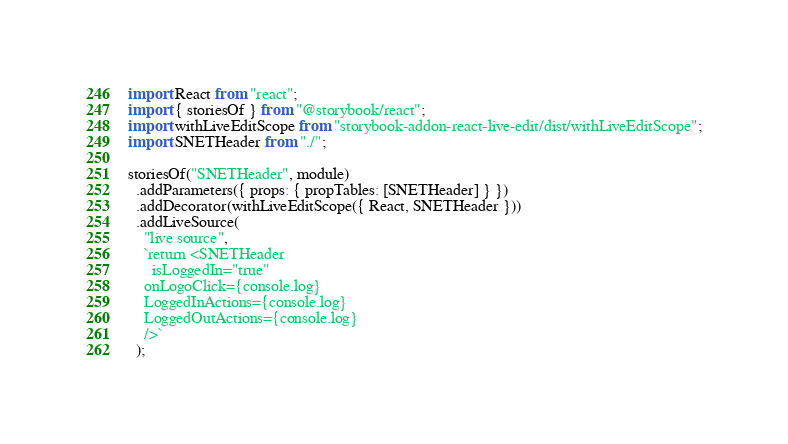<code> <loc_0><loc_0><loc_500><loc_500><_JavaScript_>import React from "react";
import { storiesOf } from "@storybook/react";
import withLiveEditScope from "storybook-addon-react-live-edit/dist/withLiveEditScope";
import SNETHeader from "./";

storiesOf("SNETHeader", module)
  .addParameters({ props: { propTables: [SNETHeader] } })
  .addDecorator(withLiveEditScope({ React, SNETHeader }))
  .addLiveSource(
    "live source",
    `return <SNETHeader 
      isLoggedIn="true"
    onLogoClick={console.log}
    LoggedInActions={console.log}
    LoggedOutActions={console.log}
    />`
  );
</code> 